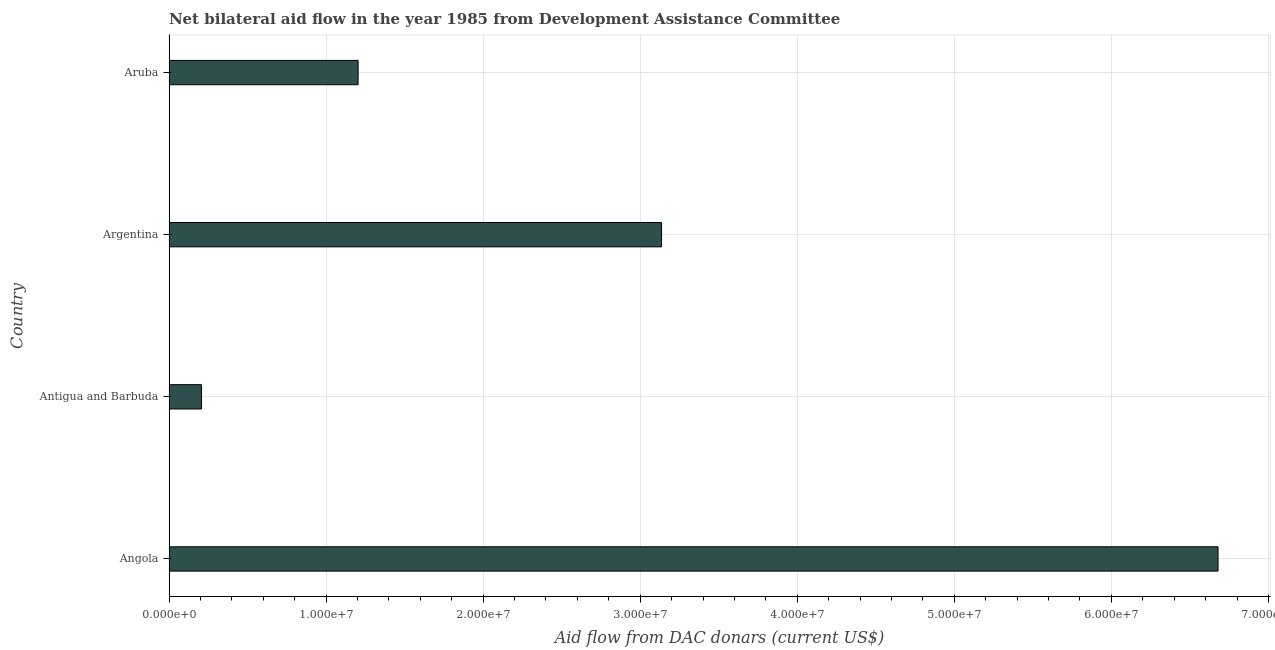Does the graph contain any zero values?
Keep it short and to the point. No. Does the graph contain grids?
Your answer should be compact. Yes. What is the title of the graph?
Provide a succinct answer. Net bilateral aid flow in the year 1985 from Development Assistance Committee. What is the label or title of the X-axis?
Keep it short and to the point. Aid flow from DAC donars (current US$). What is the label or title of the Y-axis?
Your answer should be compact. Country. What is the net bilateral aid flows from dac donors in Aruba?
Ensure brevity in your answer.  1.20e+07. Across all countries, what is the maximum net bilateral aid flows from dac donors?
Your answer should be compact. 6.68e+07. Across all countries, what is the minimum net bilateral aid flows from dac donors?
Ensure brevity in your answer.  2.07e+06. In which country was the net bilateral aid flows from dac donors maximum?
Give a very brief answer. Angola. In which country was the net bilateral aid flows from dac donors minimum?
Offer a very short reply. Antigua and Barbuda. What is the sum of the net bilateral aid flows from dac donors?
Make the answer very short. 1.12e+08. What is the difference between the net bilateral aid flows from dac donors in Angola and Aruba?
Ensure brevity in your answer.  5.48e+07. What is the average net bilateral aid flows from dac donors per country?
Keep it short and to the point. 2.81e+07. What is the median net bilateral aid flows from dac donors?
Offer a very short reply. 2.17e+07. In how many countries, is the net bilateral aid flows from dac donors greater than 66000000 US$?
Give a very brief answer. 1. What is the ratio of the net bilateral aid flows from dac donors in Antigua and Barbuda to that in Aruba?
Your answer should be very brief. 0.17. What is the difference between the highest and the second highest net bilateral aid flows from dac donors?
Give a very brief answer. 3.54e+07. What is the difference between the highest and the lowest net bilateral aid flows from dac donors?
Give a very brief answer. 6.47e+07. In how many countries, is the net bilateral aid flows from dac donors greater than the average net bilateral aid flows from dac donors taken over all countries?
Provide a succinct answer. 2. How many countries are there in the graph?
Make the answer very short. 4. What is the difference between two consecutive major ticks on the X-axis?
Provide a succinct answer. 1.00e+07. What is the Aid flow from DAC donars (current US$) in Angola?
Keep it short and to the point. 6.68e+07. What is the Aid flow from DAC donars (current US$) in Antigua and Barbuda?
Your response must be concise. 2.07e+06. What is the Aid flow from DAC donars (current US$) of Argentina?
Provide a short and direct response. 3.14e+07. What is the Aid flow from DAC donars (current US$) in Aruba?
Offer a terse response. 1.20e+07. What is the difference between the Aid flow from DAC donars (current US$) in Angola and Antigua and Barbuda?
Offer a terse response. 6.47e+07. What is the difference between the Aid flow from DAC donars (current US$) in Angola and Argentina?
Your response must be concise. 3.54e+07. What is the difference between the Aid flow from DAC donars (current US$) in Angola and Aruba?
Provide a short and direct response. 5.48e+07. What is the difference between the Aid flow from DAC donars (current US$) in Antigua and Barbuda and Argentina?
Your answer should be very brief. -2.93e+07. What is the difference between the Aid flow from DAC donars (current US$) in Antigua and Barbuda and Aruba?
Your response must be concise. -9.97e+06. What is the difference between the Aid flow from DAC donars (current US$) in Argentina and Aruba?
Your response must be concise. 1.93e+07. What is the ratio of the Aid flow from DAC donars (current US$) in Angola to that in Antigua and Barbuda?
Your answer should be compact. 32.27. What is the ratio of the Aid flow from DAC donars (current US$) in Angola to that in Argentina?
Provide a short and direct response. 2.13. What is the ratio of the Aid flow from DAC donars (current US$) in Angola to that in Aruba?
Provide a succinct answer. 5.55. What is the ratio of the Aid flow from DAC donars (current US$) in Antigua and Barbuda to that in Argentina?
Your answer should be compact. 0.07. What is the ratio of the Aid flow from DAC donars (current US$) in Antigua and Barbuda to that in Aruba?
Your answer should be very brief. 0.17. What is the ratio of the Aid flow from DAC donars (current US$) in Argentina to that in Aruba?
Make the answer very short. 2.6. 